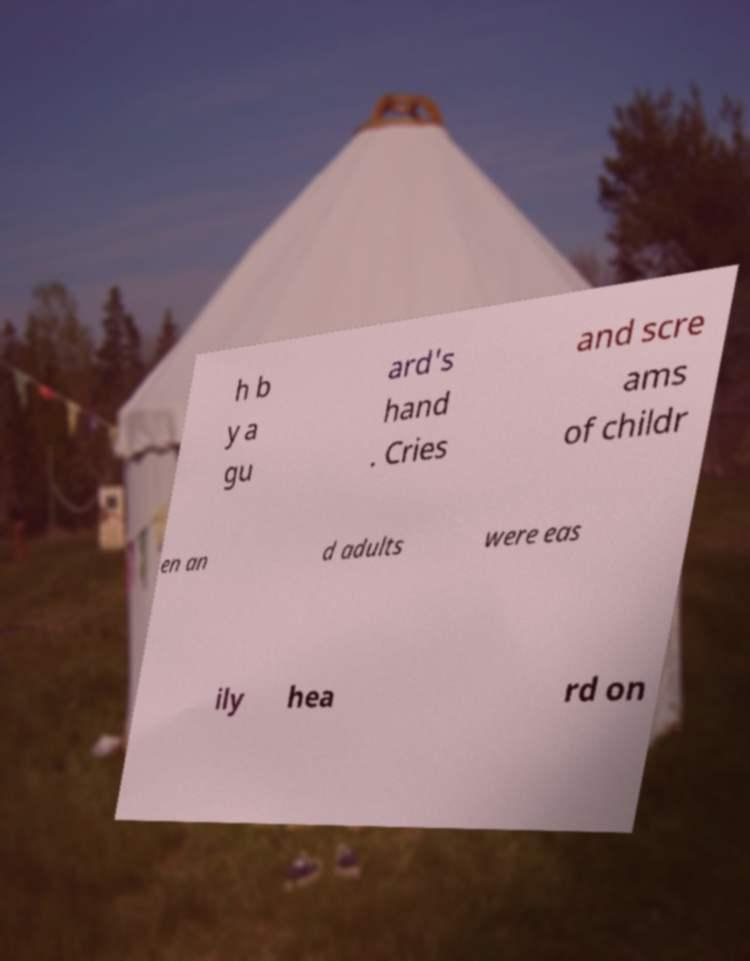Please identify and transcribe the text found in this image. h b y a gu ard's hand . Cries and scre ams of childr en an d adults were eas ily hea rd on 